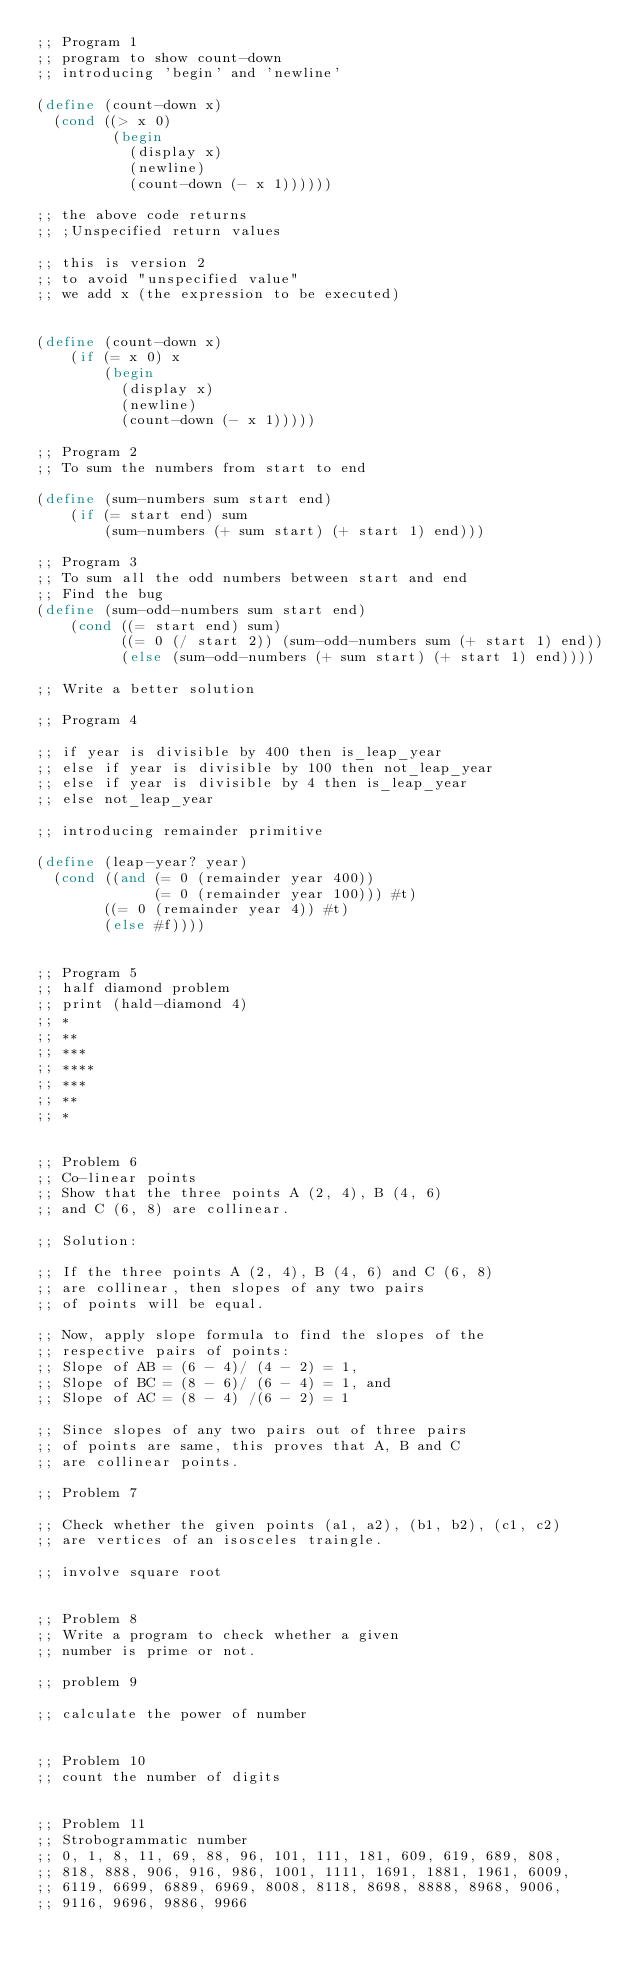<code> <loc_0><loc_0><loc_500><loc_500><_Scheme_>;; Program 1
;; program to show count-down
;; introducing 'begin' and 'newline'

(define (count-down x)
  (cond ((> x 0)
         (begin
           (display x)
           (newline)
           (count-down (- x 1))))))

;; the above code returns
;; ;Unspecified return values

;; this is version 2
;; to avoid "unspecified value"
;; we add x (the expression to be executed)


(define (count-down x)
    (if (= x 0) x
        (begin
          (display x)
          (newline)
          (count-down (- x 1)))))

;; Program 2
;; To sum the numbers from start to end

(define (sum-numbers sum start end)
    (if (= start end) sum
        (sum-numbers (+ sum start) (+ start 1) end)))

;; Program 3
;; To sum all the odd numbers between start and end
;; Find the bug
(define (sum-odd-numbers sum start end)
    (cond ((= start end) sum)
          ((= 0 (/ start 2)) (sum-odd-numbers sum (+ start 1) end))
          (else (sum-odd-numbers (+ sum start) (+ start 1) end))))

;; Write a better solution

;; Program 4

;; if year is divisible by 400 then is_leap_year
;; else if year is divisible by 100 then not_leap_year
;; else if year is divisible by 4 then is_leap_year
;; else not_leap_year

;; introducing remainder primitive

(define (leap-year? year)
  (cond ((and (= 0 (remainder year 400))
              (= 0 (remainder year 100))) #t)
        ((= 0 (remainder year 4)) #t)
        (else #f))))
 

;; Program 5
;; half diamond problem
;; print (hald-diamond 4)
;; *
;; **
;; ***
;; ****
;; ***
;; **
;; *


;; Problem 6
;; Co-linear points
;; Show that the three points A (2, 4), B (4, 6)
;; and C (6, 8) are collinear.

;; Solution:

;; If the three points A (2, 4), B (4, 6) and C (6, 8)
;; are collinear, then slopes of any two pairs
;; of points will be equal.

;; Now, apply slope formula to find the slopes of the
;; respective pairs of points:
;; Slope of AB = (6 - 4)/ (4 - 2) = 1,
;; Slope of BC = (8 - 6)/ (6 - 4) = 1, and
;; Slope of AC = (8 - 4) /(6 - 2) = 1

;; Since slopes of any two pairs out of three pairs
;; of points are same, this proves that A, B and C
;; are collinear points.

;; Problem 7

;; Check whether the given points (a1, a2), (b1, b2), (c1, c2)
;; are vertices of an isosceles traingle.

;; involve square root


;; Problem 8
;; Write a program to check whether a given
;; number is prime or not.

;; problem 9

;; calculate the power of number


;; Problem 10
;; count the number of digits


;; Problem 11
;; Strobogrammatic number
;; 0, 1, 8, 11, 69, 88, 96, 101, 111, 181, 609, 619, 689, 808,
;; 818, 888, 906, 916, 986, 1001, 1111, 1691, 1881, 1961, 6009,
;; 6119, 6699, 6889, 6969, 8008, 8118, 8698, 8888, 8968, 9006,
;; 9116, 9696, 9886, 9966
</code> 